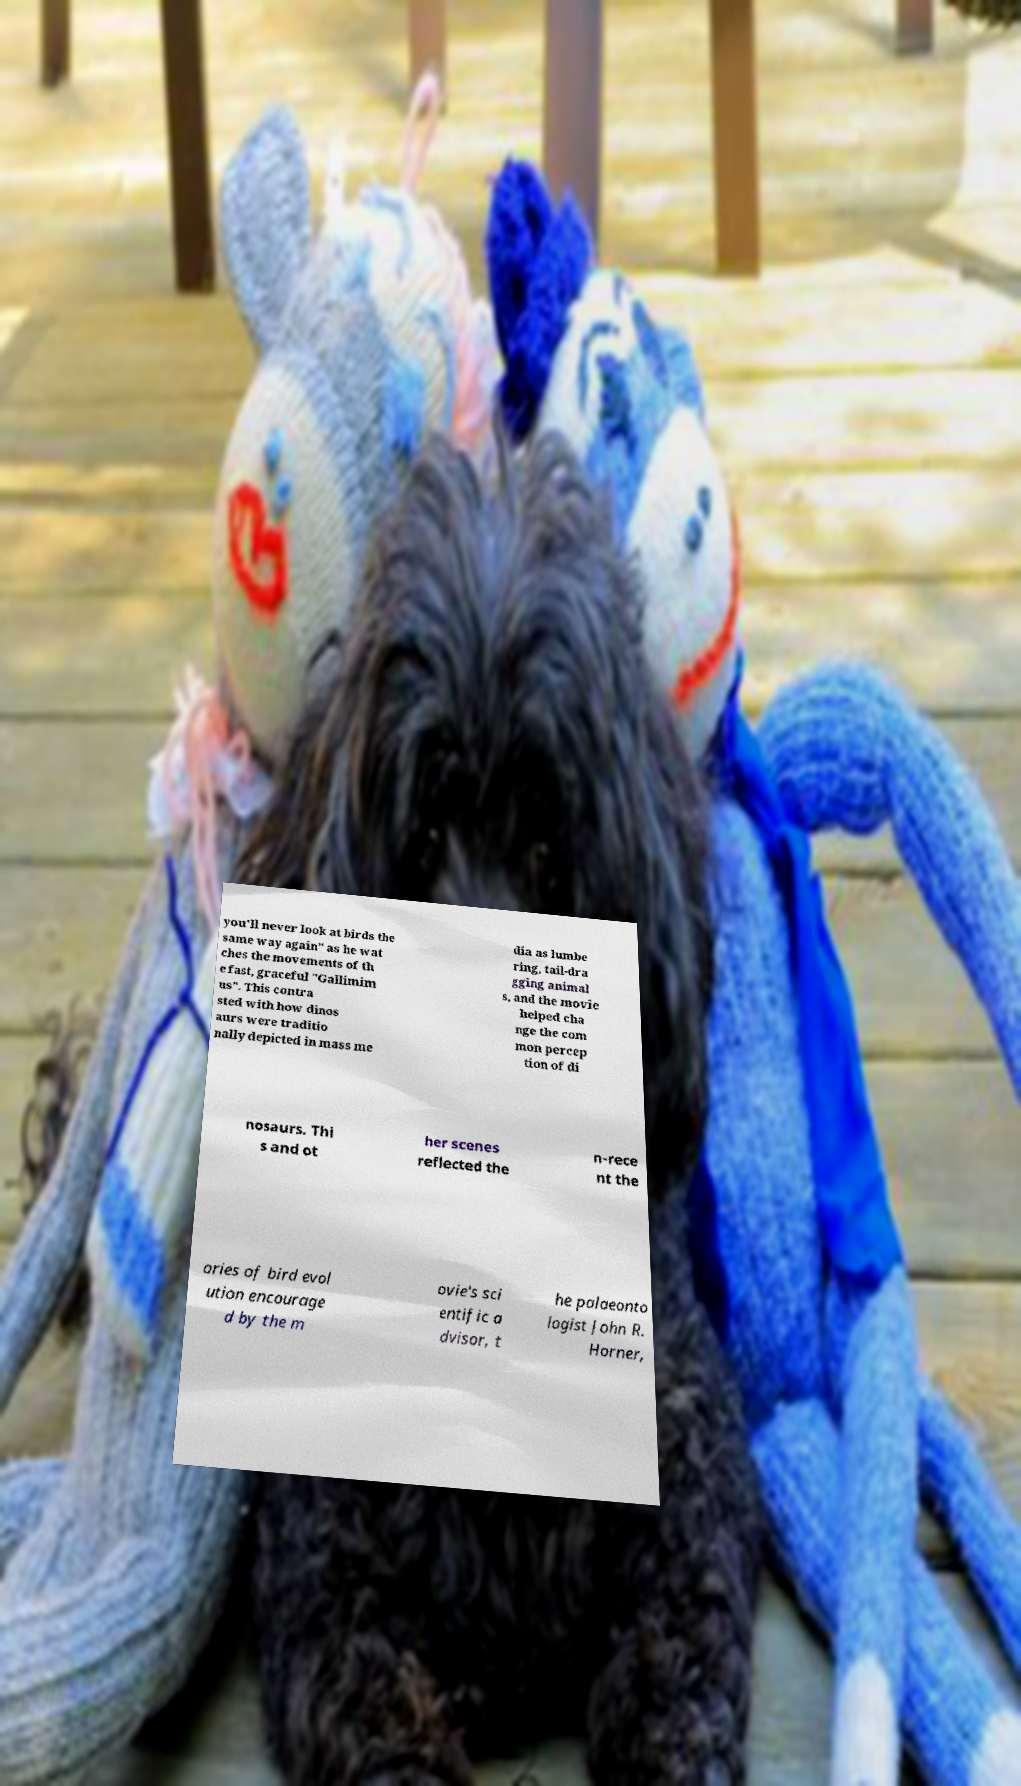Could you assist in decoding the text presented in this image and type it out clearly? you'll never look at birds the same way again" as he wat ches the movements of th e fast, graceful "Gallimim us". This contra sted with how dinos aurs were traditio nally depicted in mass me dia as lumbe ring, tail-dra gging animal s, and the movie helped cha nge the com mon percep tion of di nosaurs. Thi s and ot her scenes reflected the n-rece nt the ories of bird evol ution encourage d by the m ovie's sci entific a dvisor, t he palaeonto logist John R. Horner, 